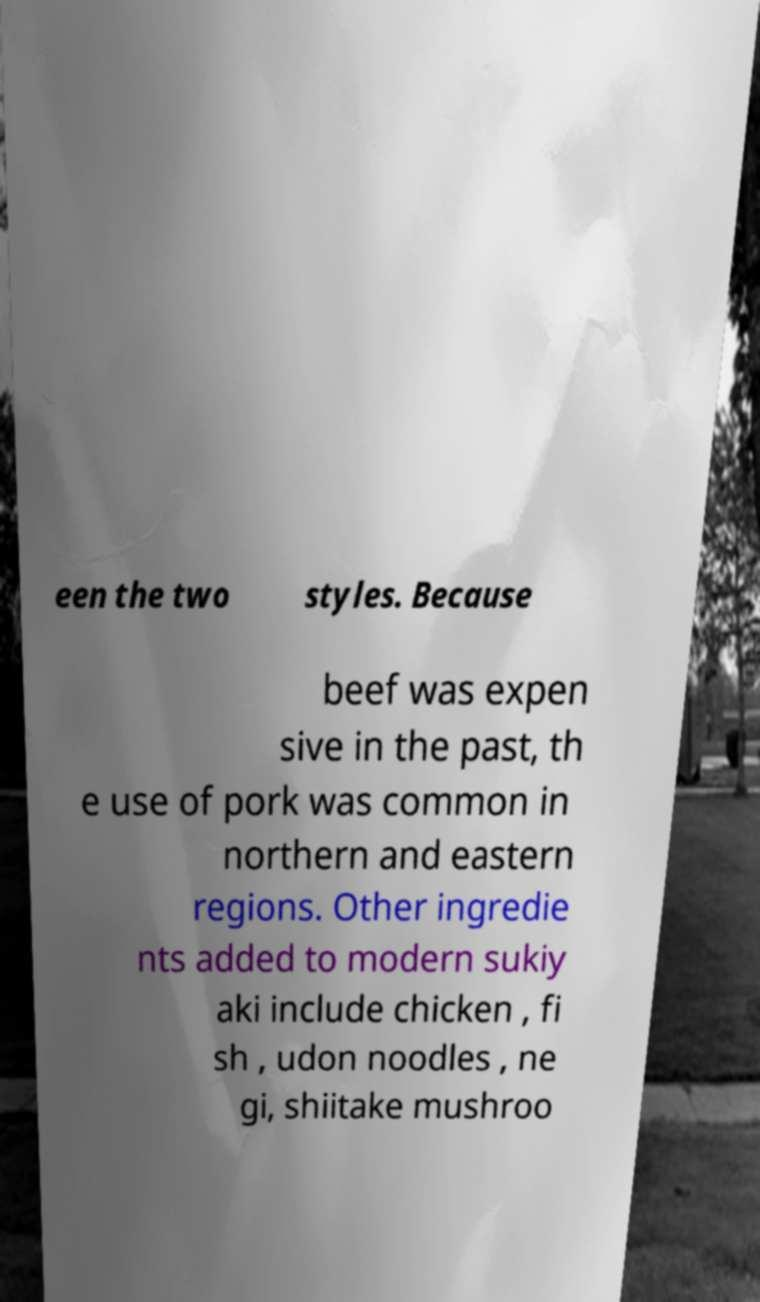Please identify and transcribe the text found in this image. een the two styles. Because beef was expen sive in the past, th e use of pork was common in northern and eastern regions. Other ingredie nts added to modern sukiy aki include chicken , fi sh , udon noodles , ne gi, shiitake mushroo 